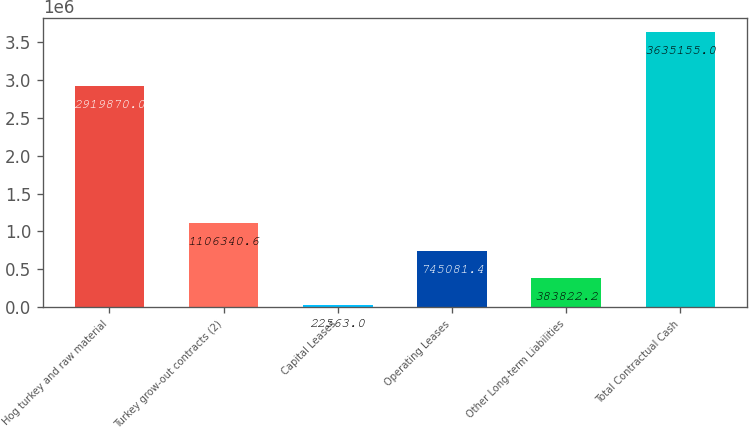<chart> <loc_0><loc_0><loc_500><loc_500><bar_chart><fcel>Hog turkey and raw material<fcel>Turkey grow-out contracts (2)<fcel>Capital Leases<fcel>Operating Leases<fcel>Other Long-term Liabilities<fcel>Total Contractual Cash<nl><fcel>2.91987e+06<fcel>1.10634e+06<fcel>22563<fcel>745081<fcel>383822<fcel>3.63516e+06<nl></chart> 